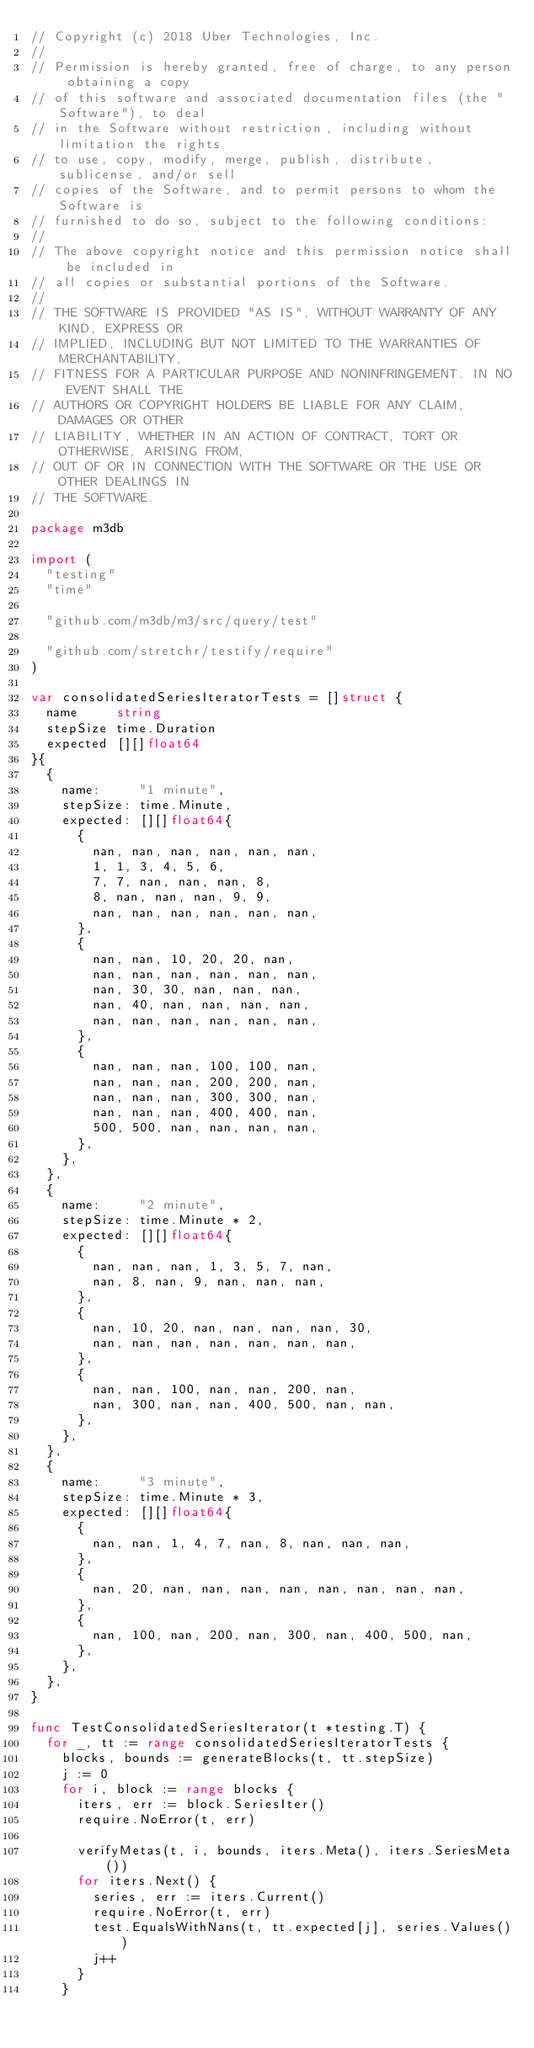Convert code to text. <code><loc_0><loc_0><loc_500><loc_500><_Go_>// Copyright (c) 2018 Uber Technologies, Inc.
//
// Permission is hereby granted, free of charge, to any person obtaining a copy
// of this software and associated documentation files (the "Software"), to deal
// in the Software without restriction, including without limitation the rights
// to use, copy, modify, merge, publish, distribute, sublicense, and/or sell
// copies of the Software, and to permit persons to whom the Software is
// furnished to do so, subject to the following conditions:
//
// The above copyright notice and this permission notice shall be included in
// all copies or substantial portions of the Software.
//
// THE SOFTWARE IS PROVIDED "AS IS", WITHOUT WARRANTY OF ANY KIND, EXPRESS OR
// IMPLIED, INCLUDING BUT NOT LIMITED TO THE WARRANTIES OF MERCHANTABILITY,
// FITNESS FOR A PARTICULAR PURPOSE AND NONINFRINGEMENT. IN NO EVENT SHALL THE
// AUTHORS OR COPYRIGHT HOLDERS BE LIABLE FOR ANY CLAIM, DAMAGES OR OTHER
// LIABILITY, WHETHER IN AN ACTION OF CONTRACT, TORT OR OTHERWISE, ARISING FROM,
// OUT OF OR IN CONNECTION WITH THE SOFTWARE OR THE USE OR OTHER DEALINGS IN
// THE SOFTWARE.

package m3db

import (
	"testing"
	"time"

	"github.com/m3db/m3/src/query/test"

	"github.com/stretchr/testify/require"
)

var consolidatedSeriesIteratorTests = []struct {
	name     string
	stepSize time.Duration
	expected [][]float64
}{
	{
		name:     "1 minute",
		stepSize: time.Minute,
		expected: [][]float64{
			{
				nan, nan, nan, nan, nan, nan,
				1, 1, 3, 4, 5, 6,
				7, 7, nan, nan, nan, 8,
				8, nan, nan, nan, 9, 9,
				nan, nan, nan, nan, nan, nan,
			},
			{
				nan, nan, 10, 20, 20, nan,
				nan, nan, nan, nan, nan, nan,
				nan, 30, 30, nan, nan, nan,
				nan, 40, nan, nan, nan, nan,
				nan, nan, nan, nan, nan, nan,
			},
			{
				nan, nan, nan, 100, 100, nan,
				nan, nan, nan, 200, 200, nan,
				nan, nan, nan, 300, 300, nan,
				nan, nan, nan, 400, 400, nan,
				500, 500, nan, nan, nan, nan,
			},
		},
	},
	{
		name:     "2 minute",
		stepSize: time.Minute * 2,
		expected: [][]float64{
			{
				nan, nan, nan, 1, 3, 5, 7, nan,
				nan, 8, nan, 9, nan, nan, nan,
			},
			{
				nan, 10, 20, nan, nan, nan, nan, 30,
				nan, nan, nan, nan, nan, nan, nan,
			},
			{
				nan, nan, 100, nan, nan, 200, nan,
				nan, 300, nan, nan, 400, 500, nan, nan,
			},
		},
	},
	{
		name:     "3 minute",
		stepSize: time.Minute * 3,
		expected: [][]float64{
			{
				nan, nan, 1, 4, 7, nan, 8, nan, nan, nan,
			},
			{
				nan, 20, nan, nan, nan, nan, nan, nan, nan, nan,
			},
			{
				nan, 100, nan, 200, nan, 300, nan, 400, 500, nan,
			},
		},
	},
}

func TestConsolidatedSeriesIterator(t *testing.T) {
	for _, tt := range consolidatedSeriesIteratorTests {
		blocks, bounds := generateBlocks(t, tt.stepSize)
		j := 0
		for i, block := range blocks {
			iters, err := block.SeriesIter()
			require.NoError(t, err)

			verifyMetas(t, i, bounds, iters.Meta(), iters.SeriesMeta())
			for iters.Next() {
				series, err := iters.Current()
				require.NoError(t, err)
				test.EqualsWithNans(t, tt.expected[j], series.Values())
				j++
			}
		}</code> 